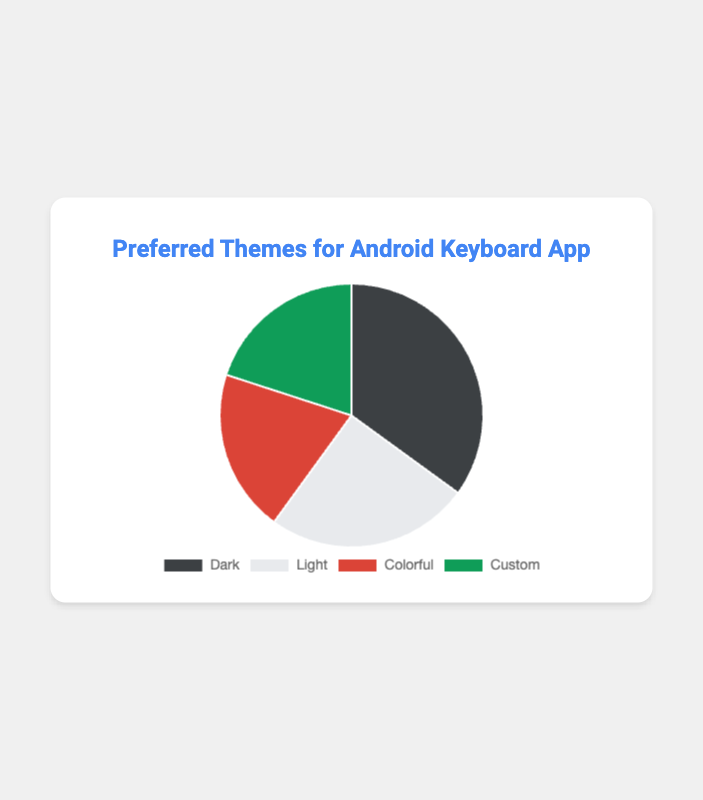What percentage of users prefer the Dark theme? The Dark theme segment represents 35% of the pie chart.
Answer: 35% Which theme is the least preferred by users? Both the Colorful and Custom themes are at 20%, making them the least preferred.
Answer: Colorful and Custom How many more users prefer the Dark theme compared to the Light theme? The Dark theme has 35% and the Light theme has 25%, the difference is 35% - 25% = 10%.
Answer: 10% What are the total percentages for Colorful and Custom themes combined? Adding the percentages for Colorful and Custom themes: 20% + 20% = 40%.
Answer: 40% Is the percentage of Light theme users greater than the combined percentage of Colorful and Custom theme users? The Light theme has 25% and the combined percentage for Colorful and Custom themes is 40%. Thus, 25% < 40%.
Answer: No Which theme has a background color that is darker compared to the others? The Dark theme has a black or dark grey shade, which is visually darker than Light, Colorful, or Custom themes.
Answer: Dark How does the number of users preferring the Light theme compare to those preferring the Custom theme? The Light theme has 25% while the Custom theme has 20%, making the Light theme more preferred.
Answer: Light is more preferred What is the difference in preference percentage between the most preferred and the least preferred themes? The most preferred theme is Dark (35%) and the least preferred are Colorful and Custom (each 20%). The difference is 35% - 20% = 15%.
Answer: 15% Which theme occupies the smallest segment in the pie chart and what is its color? Both Colorful and Custom themes occupy the smallest segments, and their colors are red and green respectively.
Answer: Colorful (red) and Custom (green) What would be the total percentage if preferences for non-dark themes are summed? Adding percentages for Light (25%), Colorful (20%), and Custom (20%) gives: 25% + 20% + 20% = 65%.
Answer: 65% 